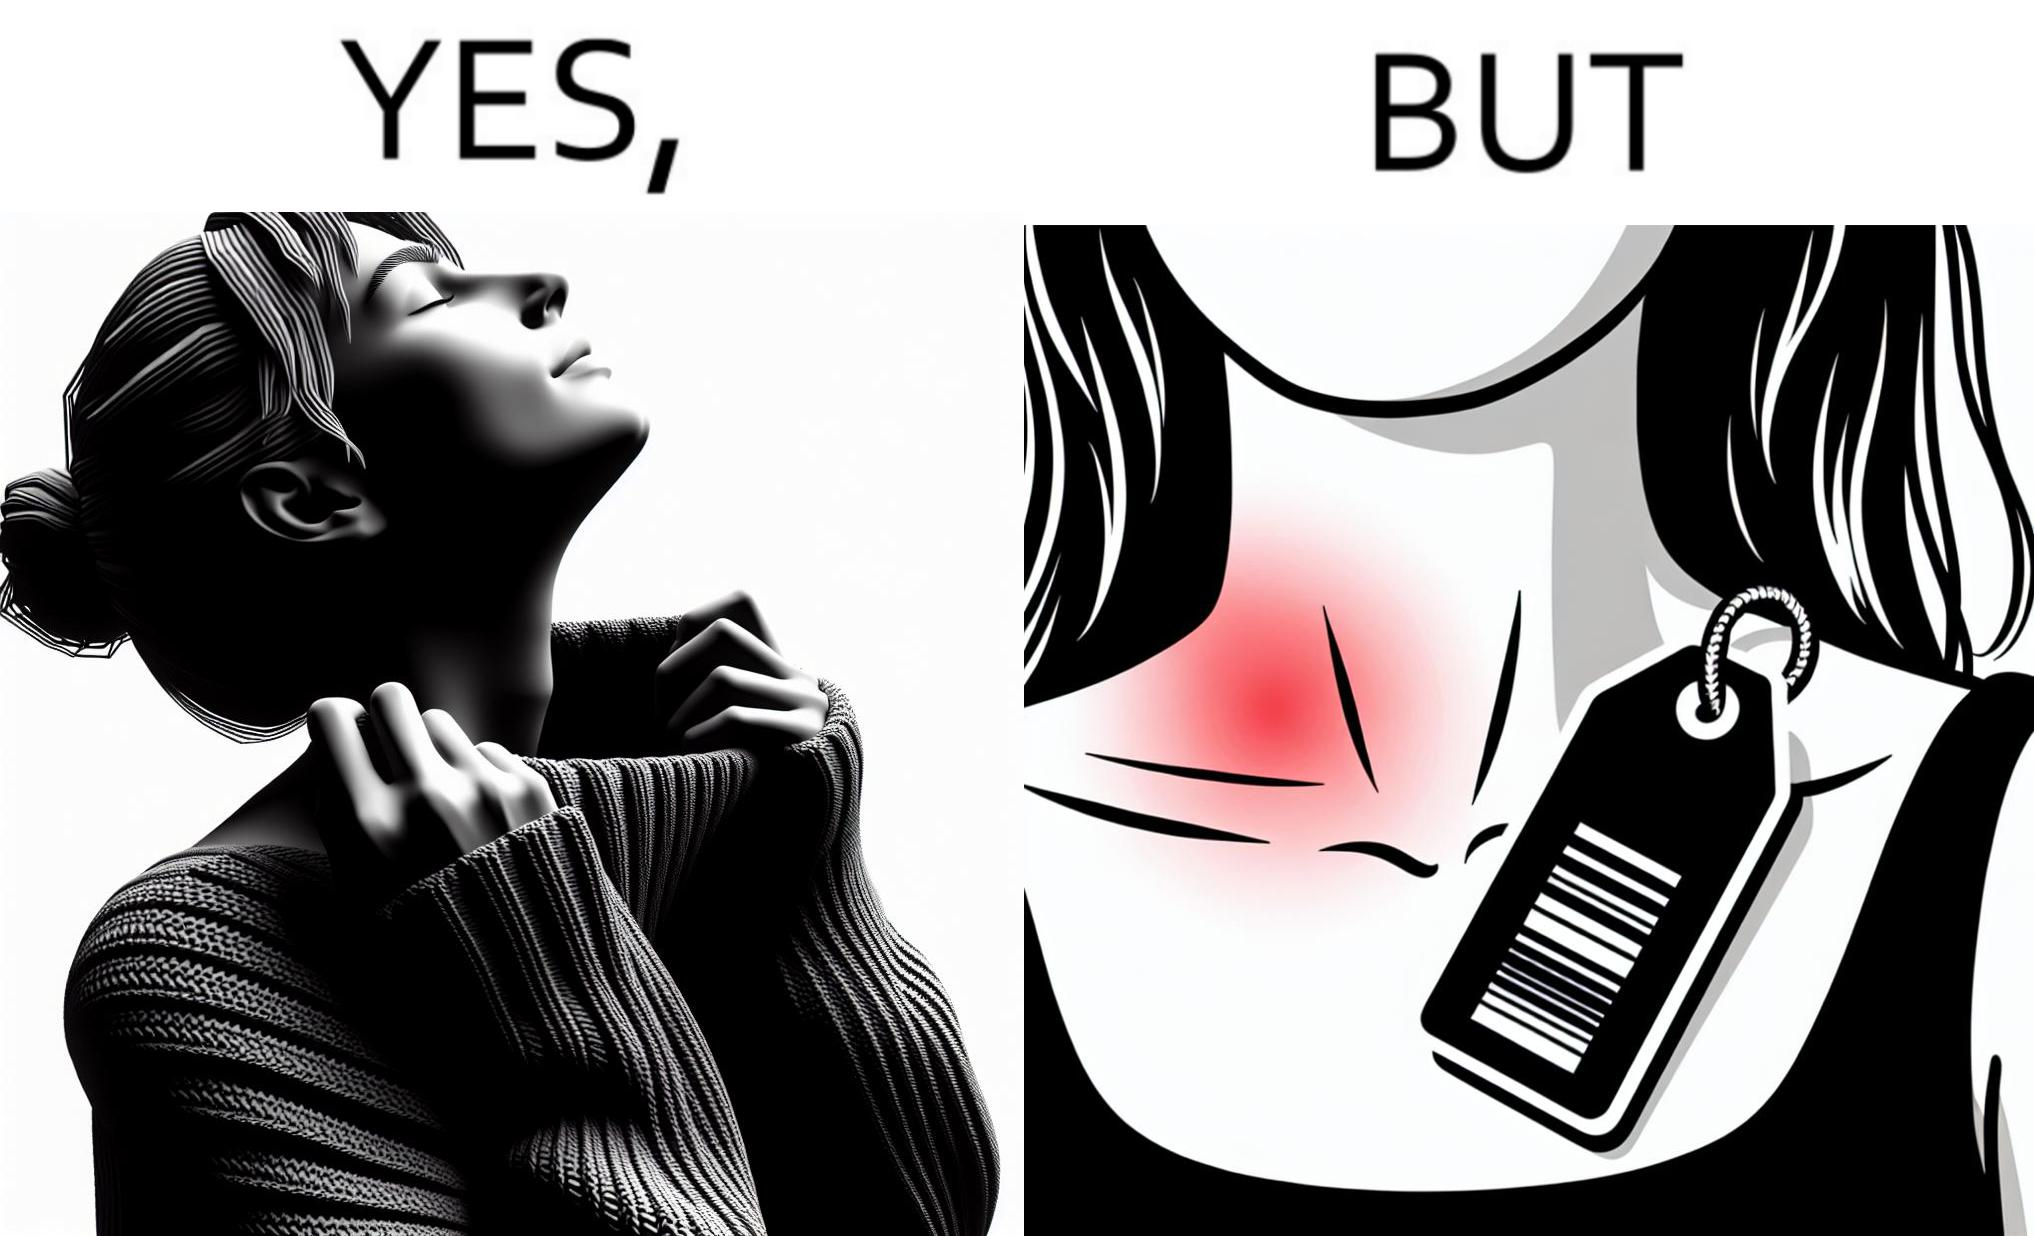What do you see in each half of this image? In the left part of the image: It is a woman enjoying the warmth and comfort of her sweater In the right part of the image: It a womans neck, irritated and red due to manufacturers tags on her clothes 